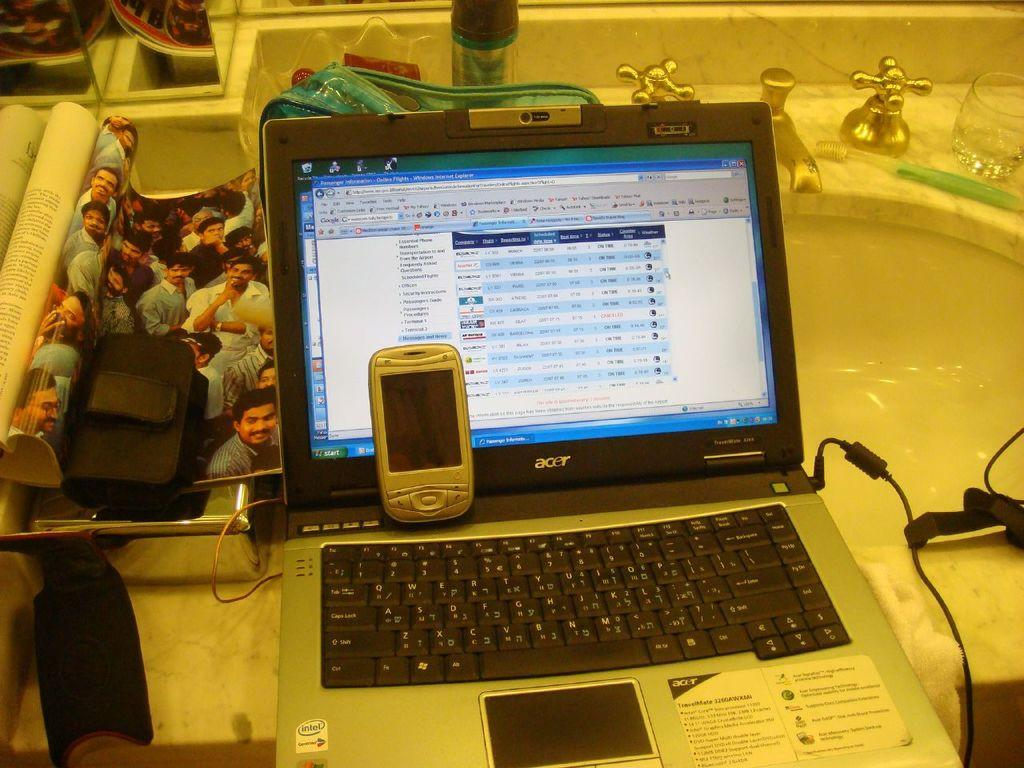<image>
Offer a succinct explanation of the picture presented. An open Acer laptop with a web browswer running and an older smartphone propped against the screen. 